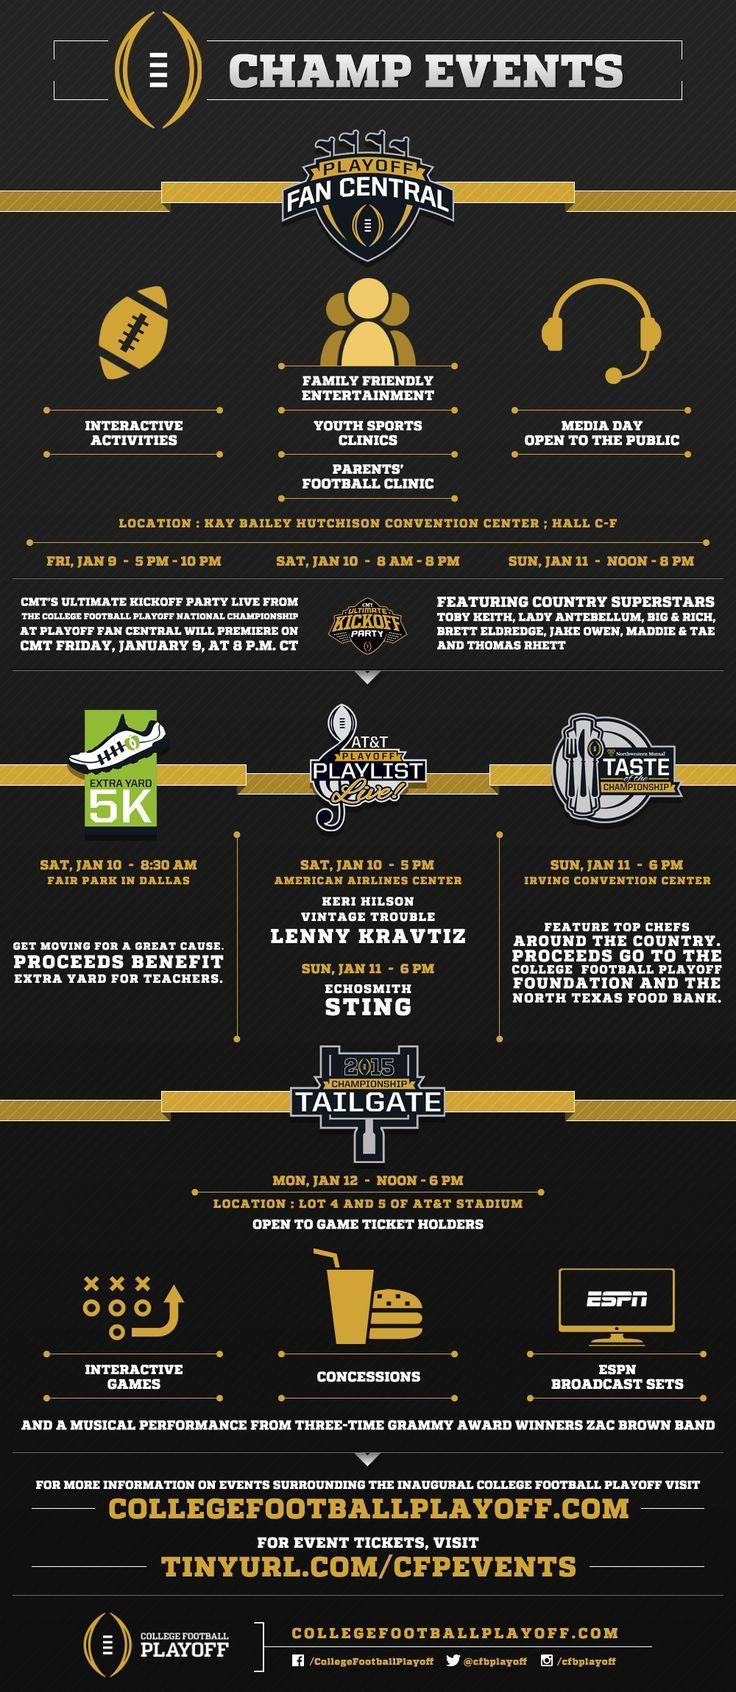What is written on the computer screen above ESPN Broadcast Sets
Answer the question with a short phrase. ESPN What is on Sat, Jan 10 - 5 PM at American Airlines Center AT&T Playoff Playlist Live! What does the rugby ball indicate interactive activities Where is the extra yard 5k being held Fair Park in Dallas When is the Media dat open to the public Sun, Jan 11 - Noon - 8 pm When are the interactive activities Fri, Jan 9 - 5 PM - 10 PM When is the youth sports clinics event Sat, Jan 10 - 8 AM - 8 PM 